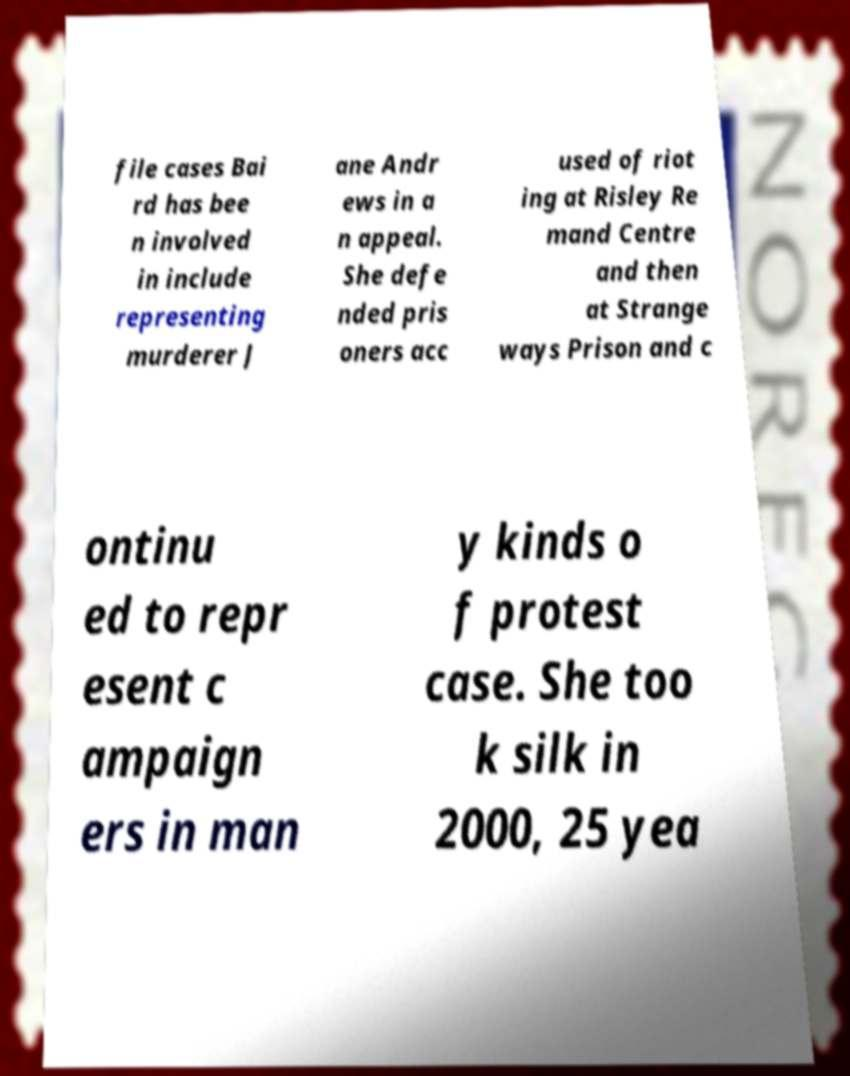Can you read and provide the text displayed in the image?This photo seems to have some interesting text. Can you extract and type it out for me? file cases Bai rd has bee n involved in include representing murderer J ane Andr ews in a n appeal. She defe nded pris oners acc used of riot ing at Risley Re mand Centre and then at Strange ways Prison and c ontinu ed to repr esent c ampaign ers in man y kinds o f protest case. She too k silk in 2000, 25 yea 